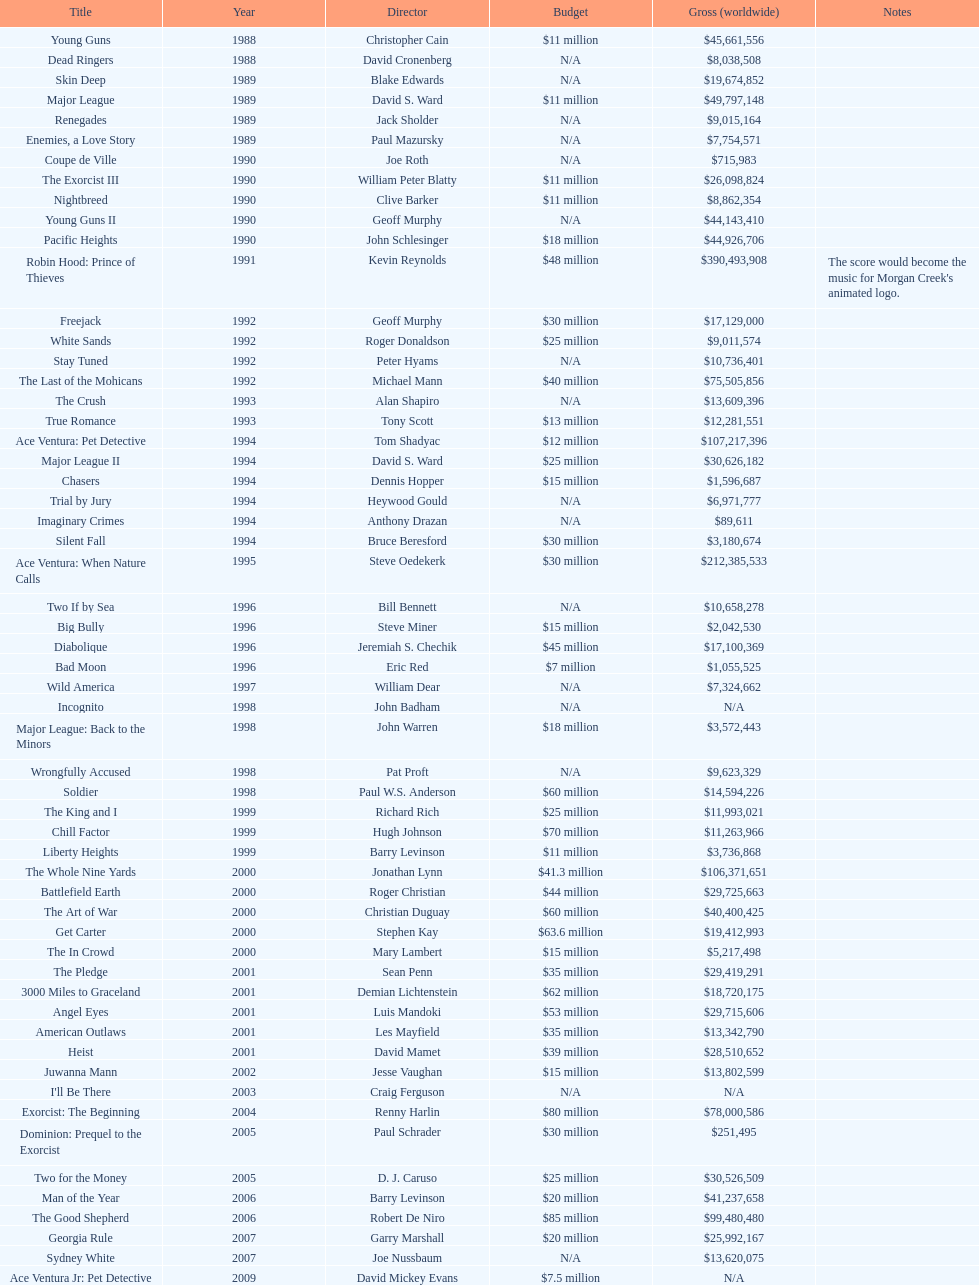Was the budget allocated to young guns higher or lower than that of freejack? Less. 